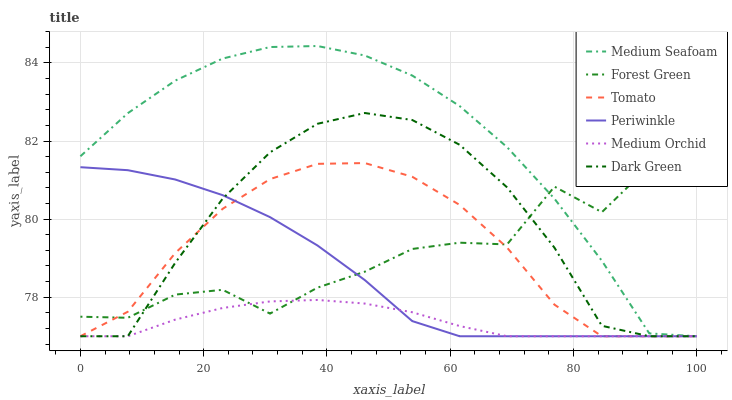Does Medium Orchid have the minimum area under the curve?
Answer yes or no. Yes. Does Medium Seafoam have the maximum area under the curve?
Answer yes or no. Yes. Does Forest Green have the minimum area under the curve?
Answer yes or no. No. Does Forest Green have the maximum area under the curve?
Answer yes or no. No. Is Medium Orchid the smoothest?
Answer yes or no. Yes. Is Forest Green the roughest?
Answer yes or no. Yes. Is Forest Green the smoothest?
Answer yes or no. No. Is Medium Orchid the roughest?
Answer yes or no. No. Does Tomato have the lowest value?
Answer yes or no. Yes. Does Forest Green have the lowest value?
Answer yes or no. No. Does Medium Seafoam have the highest value?
Answer yes or no. Yes. Does Forest Green have the highest value?
Answer yes or no. No. Does Periwinkle intersect Medium Orchid?
Answer yes or no. Yes. Is Periwinkle less than Medium Orchid?
Answer yes or no. No. Is Periwinkle greater than Medium Orchid?
Answer yes or no. No. 